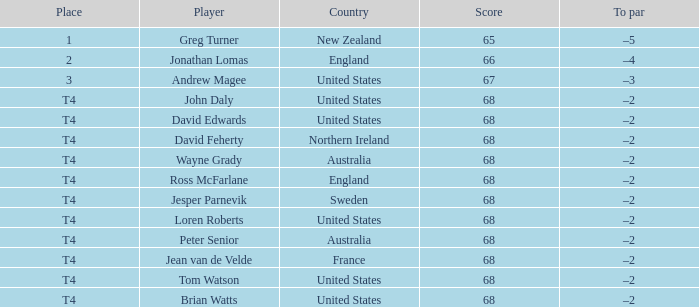Identify the score of tom watson in the u.s. 68.0. Could you parse the entire table? {'header': ['Place', 'Player', 'Country', 'Score', 'To par'], 'rows': [['1', 'Greg Turner', 'New Zealand', '65', '–5'], ['2', 'Jonathan Lomas', 'England', '66', '–4'], ['3', 'Andrew Magee', 'United States', '67', '–3'], ['T4', 'John Daly', 'United States', '68', '–2'], ['T4', 'David Edwards', 'United States', '68', '–2'], ['T4', 'David Feherty', 'Northern Ireland', '68', '–2'], ['T4', 'Wayne Grady', 'Australia', '68', '–2'], ['T4', 'Ross McFarlane', 'England', '68', '–2'], ['T4', 'Jesper Parnevik', 'Sweden', '68', '–2'], ['T4', 'Loren Roberts', 'United States', '68', '–2'], ['T4', 'Peter Senior', 'Australia', '68', '–2'], ['T4', 'Jean van de Velde', 'France', '68', '–2'], ['T4', 'Tom Watson', 'United States', '68', '–2'], ['T4', 'Brian Watts', 'United States', '68', '–2']]} 